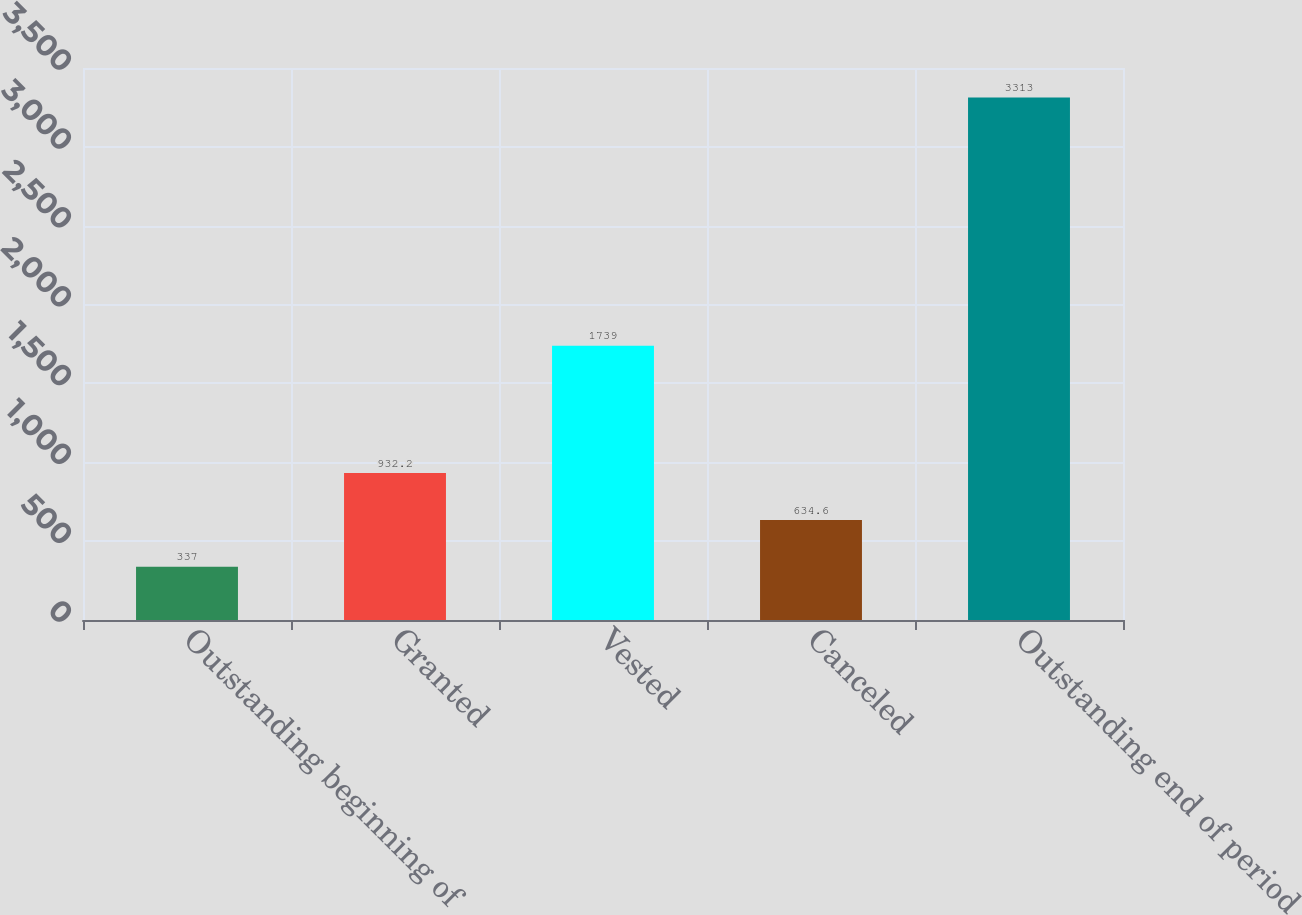Convert chart. <chart><loc_0><loc_0><loc_500><loc_500><bar_chart><fcel>Outstanding beginning of<fcel>Granted<fcel>Vested<fcel>Canceled<fcel>Outstanding end of period<nl><fcel>337<fcel>932.2<fcel>1739<fcel>634.6<fcel>3313<nl></chart> 